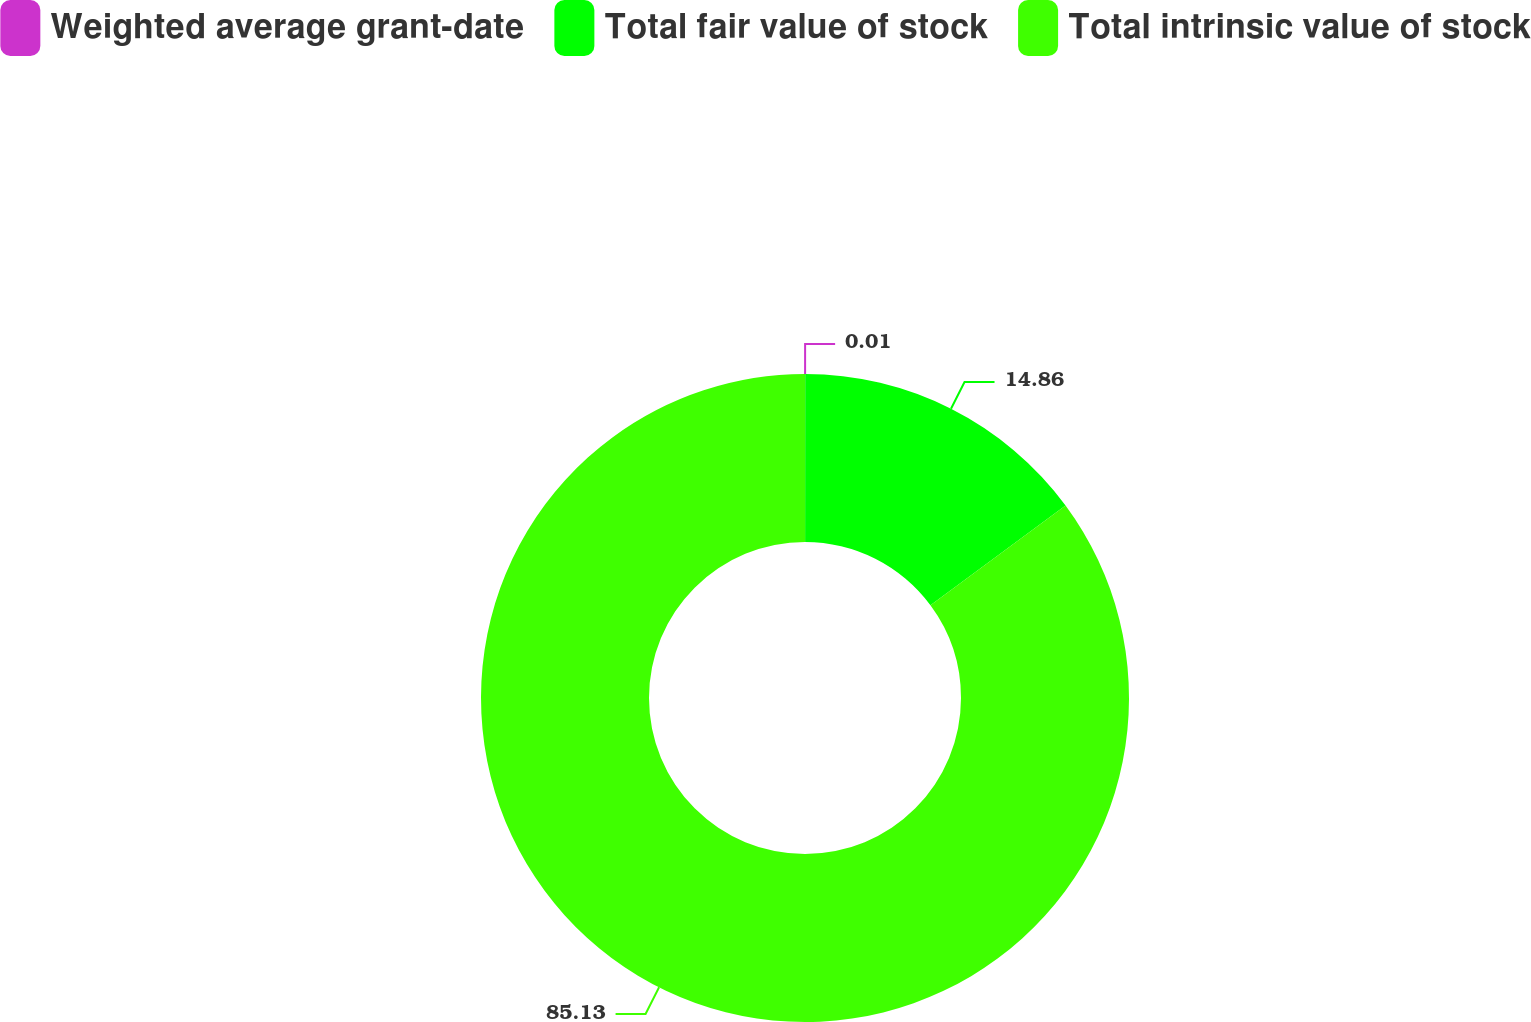Convert chart to OTSL. <chart><loc_0><loc_0><loc_500><loc_500><pie_chart><fcel>Weighted average grant-date<fcel>Total fair value of stock<fcel>Total intrinsic value of stock<nl><fcel>0.01%<fcel>14.86%<fcel>85.13%<nl></chart> 